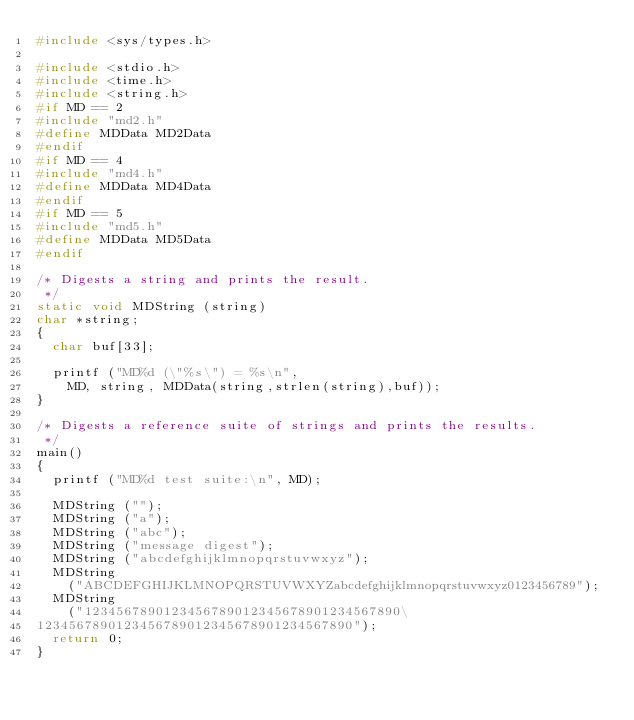<code> <loc_0><loc_0><loc_500><loc_500><_C_>#include <sys/types.h>

#include <stdio.h>
#include <time.h>
#include <string.h>
#if MD == 2
#include "md2.h"
#define MDData MD2Data
#endif
#if MD == 4
#include "md4.h"
#define MDData MD4Data
#endif
#if MD == 5
#include "md5.h"
#define MDData MD5Data
#endif

/* Digests a string and prints the result.
 */
static void MDString (string)
char *string;
{
  char buf[33];

  printf ("MD%d (\"%s\") = %s\n", 
	MD, string, MDData(string,strlen(string),buf));
}

/* Digests a reference suite of strings and prints the results.
 */
main()
{
  printf ("MD%d test suite:\n", MD);

  MDString ("");
  MDString ("a");
  MDString ("abc");
  MDString ("message digest");
  MDString ("abcdefghijklmnopqrstuvwxyz");
  MDString
    ("ABCDEFGHIJKLMNOPQRSTUVWXYZabcdefghijklmnopqrstuvwxyz0123456789");
  MDString
    ("1234567890123456789012345678901234567890\
1234567890123456789012345678901234567890");
  return 0;
}
</code> 